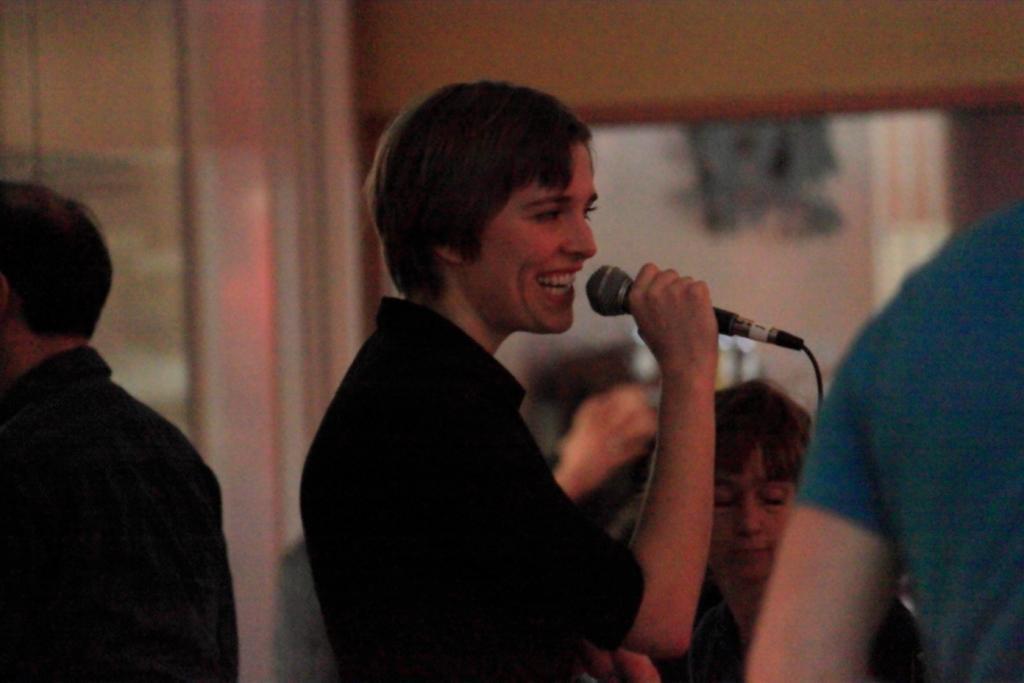In one or two sentences, can you explain what this image depicts? In the image we can see there is a person who is standing and holding mic in her hand and there are lot of people who are standing in the area. The person is wearing black colour t shirt. 